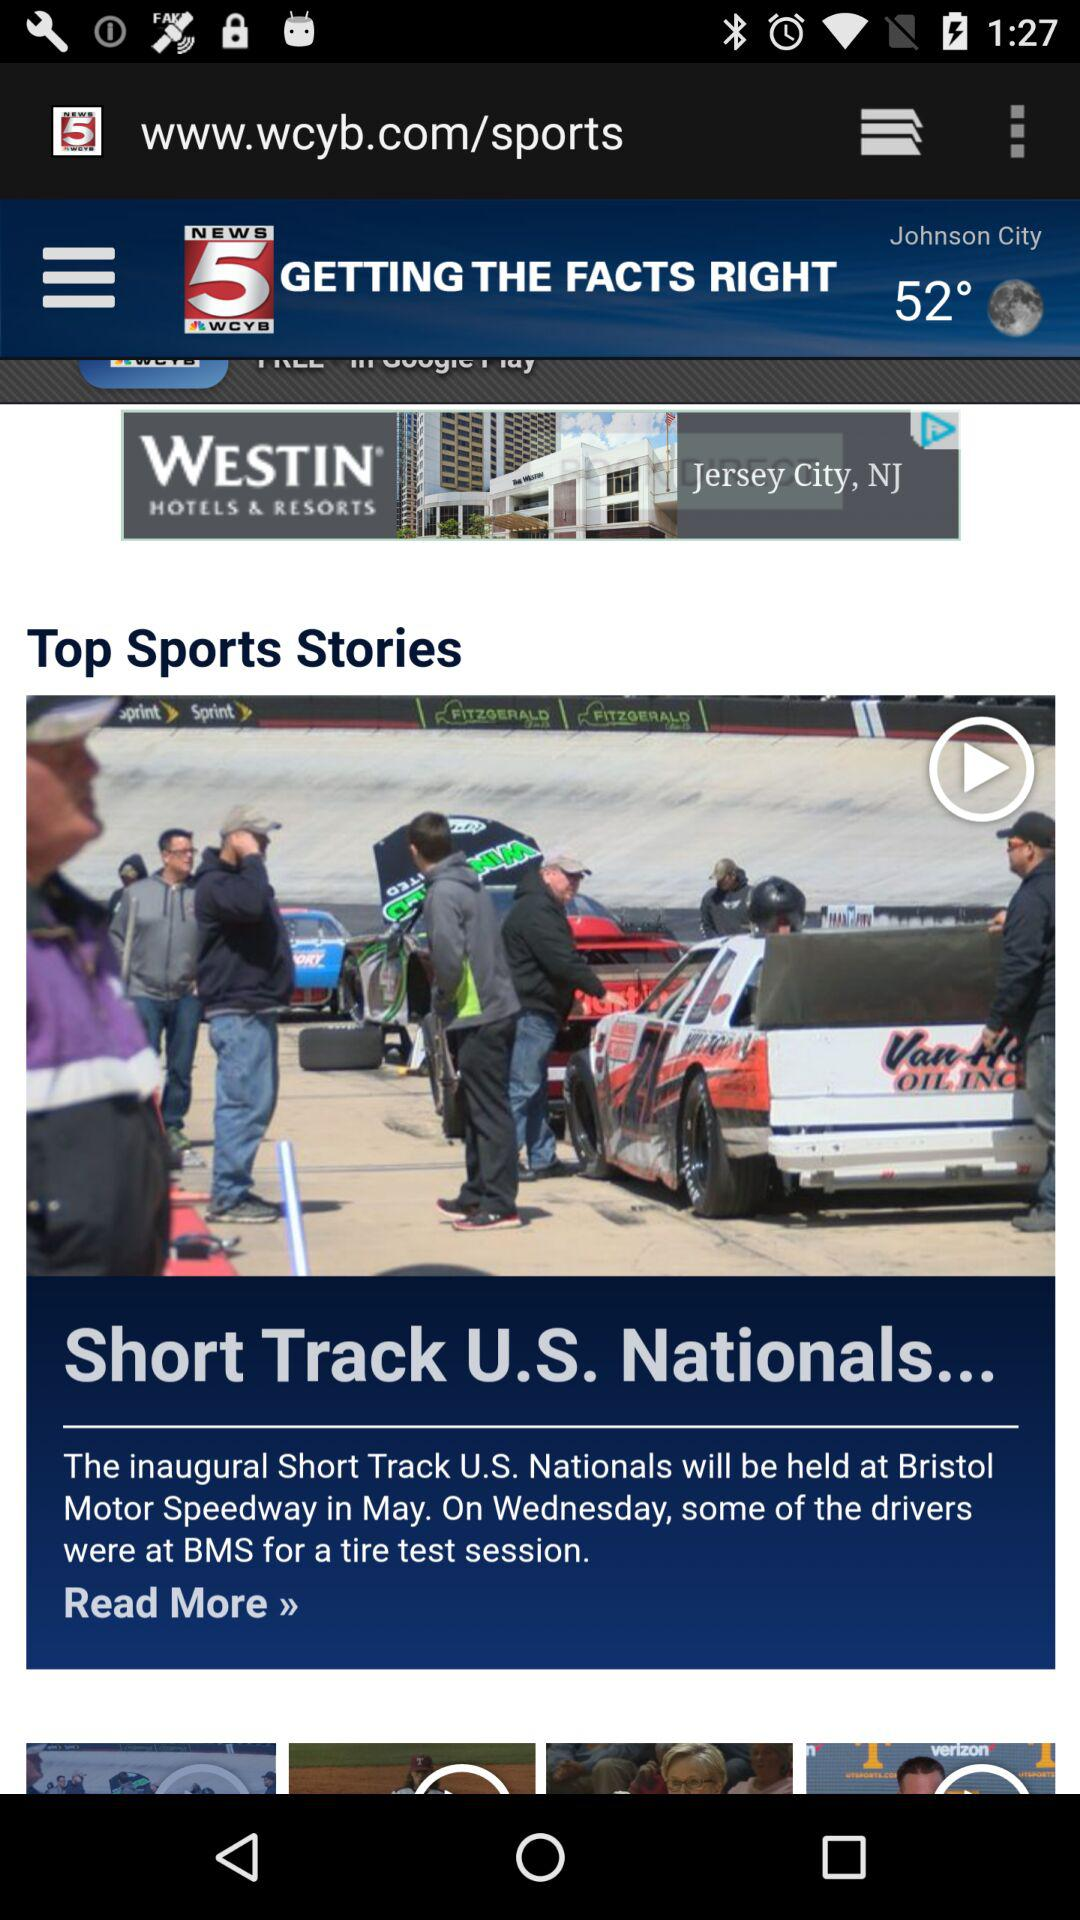What is the name of the news channel? The name of the news channel is WCYB News. 